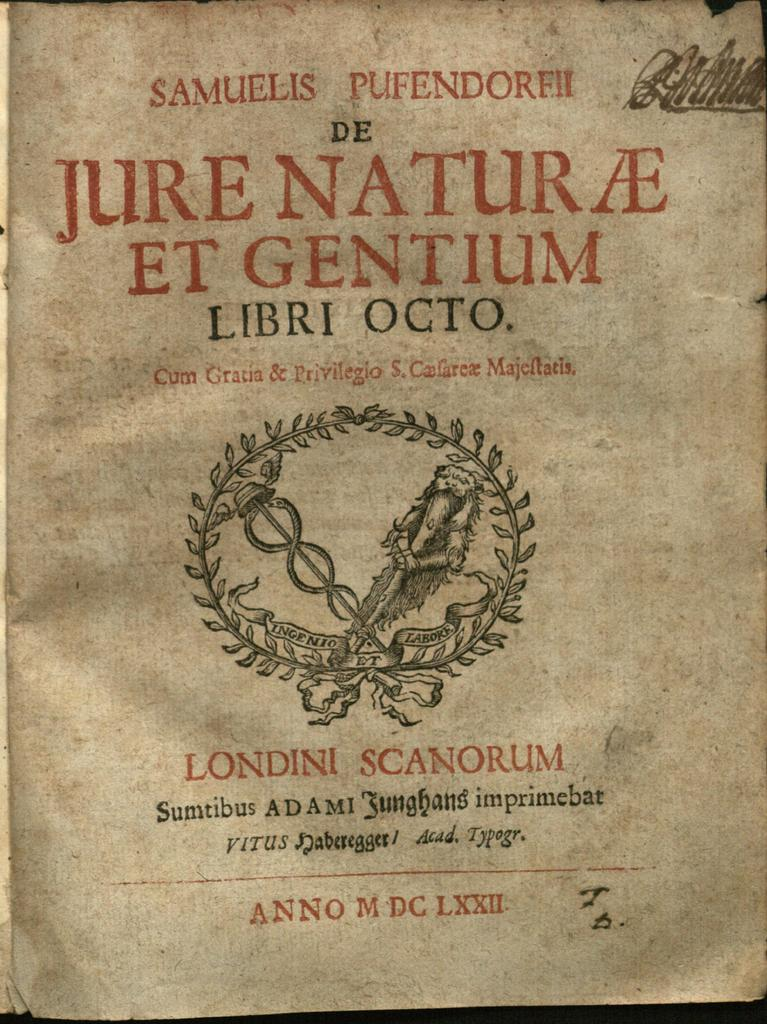<image>
Provide a brief description of the given image. Samuelis Pufendorfii de Jure Natur AE ET Gentium Libri Octo book. 